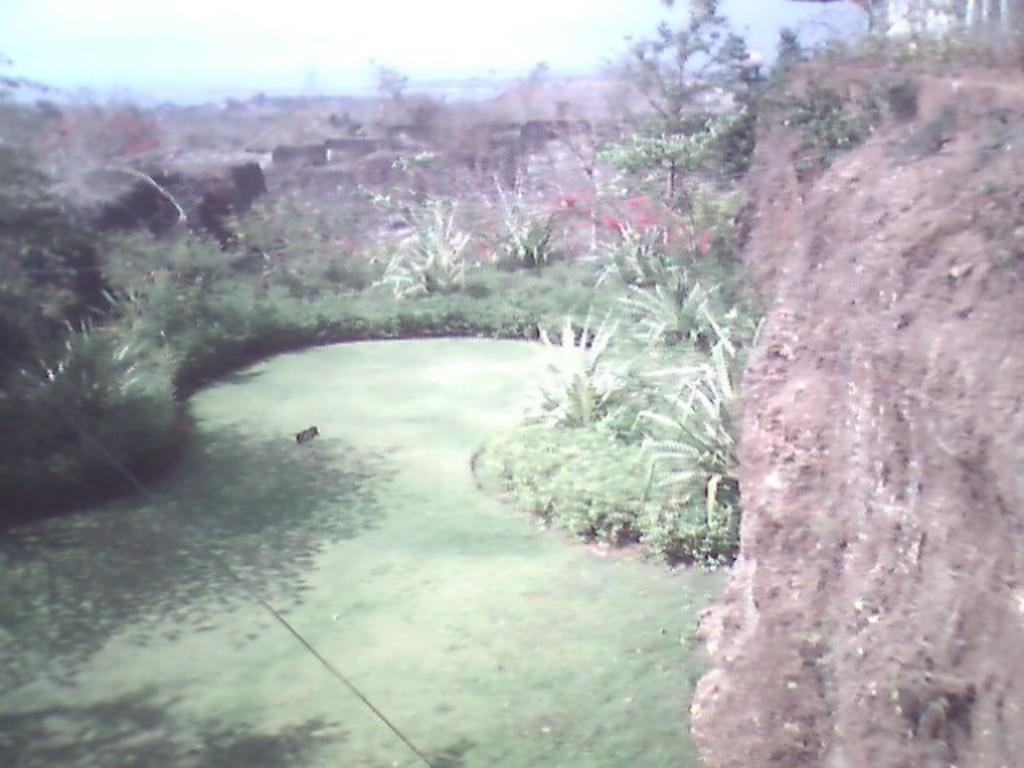What type of vegetation is present at the bottom of the image? There is grass and plants at the bottom of the image. What can be seen in the background of the image? There are trees in the background of the image. What geographical feature is located on the right side of the image? There is a mountain on the right side of the image. Can you see any fog around the mountain in the image? There is no mention of fog in the image, so it cannot be determined if it is present or not. What type of beef is being served at the bottom of the image? There is no beef present in the image; it features grass, plants, trees, and a mountain. 